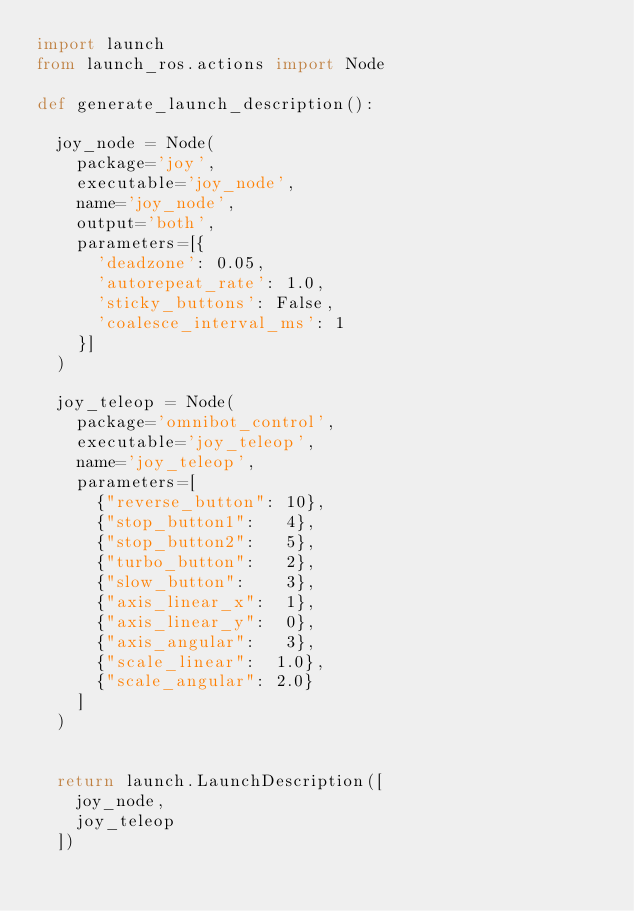Convert code to text. <code><loc_0><loc_0><loc_500><loc_500><_Python_>import launch
from launch_ros.actions import Node

def generate_launch_description():

  joy_node = Node(
    package='joy',
    executable='joy_node',
    name='joy_node',
    output='both',
    parameters=[{
      'deadzone': 0.05,
      'autorepeat_rate': 1.0,
      'sticky_buttons': False,
      'coalesce_interval_ms': 1
    }]
  )

  joy_teleop = Node(
    package='omnibot_control',
    executable='joy_teleop',
    name='joy_teleop',
    parameters=[
      {"reverse_button": 10},
      {"stop_button1":   4},
      {"stop_button2":   5},
      {"turbo_button":   2},
      {"slow_button":    3},
      {"axis_linear_x":  1},
      {"axis_linear_y":  0},
      {"axis_angular":   3},
      {"scale_linear":  1.0},
      {"scale_angular": 2.0}
    ]
  )


  return launch.LaunchDescription([
    joy_node,
    joy_teleop
  ])
</code> 